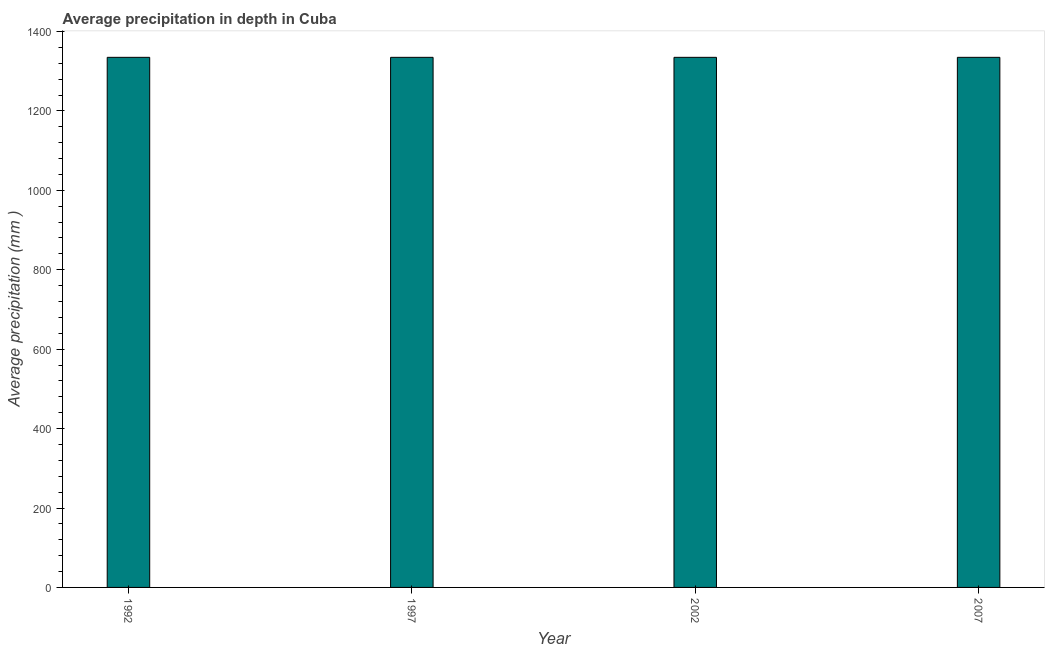What is the title of the graph?
Offer a very short reply. Average precipitation in depth in Cuba. What is the label or title of the X-axis?
Your response must be concise. Year. What is the label or title of the Y-axis?
Keep it short and to the point. Average precipitation (mm ). What is the average precipitation in depth in 2002?
Your answer should be compact. 1335. Across all years, what is the maximum average precipitation in depth?
Ensure brevity in your answer.  1335. Across all years, what is the minimum average precipitation in depth?
Make the answer very short. 1335. What is the sum of the average precipitation in depth?
Keep it short and to the point. 5340. What is the average average precipitation in depth per year?
Your answer should be very brief. 1335. What is the median average precipitation in depth?
Your answer should be very brief. 1335. What is the ratio of the average precipitation in depth in 1992 to that in 1997?
Offer a terse response. 1. Is the average precipitation in depth in 1992 less than that in 2002?
Give a very brief answer. No. What is the difference between the highest and the second highest average precipitation in depth?
Make the answer very short. 0. How many bars are there?
Your answer should be compact. 4. What is the difference between two consecutive major ticks on the Y-axis?
Provide a succinct answer. 200. Are the values on the major ticks of Y-axis written in scientific E-notation?
Your answer should be compact. No. What is the Average precipitation (mm ) in 1992?
Offer a terse response. 1335. What is the Average precipitation (mm ) in 1997?
Keep it short and to the point. 1335. What is the Average precipitation (mm ) in 2002?
Ensure brevity in your answer.  1335. What is the Average precipitation (mm ) of 2007?
Offer a terse response. 1335. What is the difference between the Average precipitation (mm ) in 1992 and 2002?
Keep it short and to the point. 0. What is the difference between the Average precipitation (mm ) in 1997 and 2007?
Offer a very short reply. 0. What is the ratio of the Average precipitation (mm ) in 1992 to that in 1997?
Make the answer very short. 1. What is the ratio of the Average precipitation (mm ) in 1992 to that in 2002?
Provide a succinct answer. 1. What is the ratio of the Average precipitation (mm ) in 1992 to that in 2007?
Provide a short and direct response. 1. What is the ratio of the Average precipitation (mm ) in 1997 to that in 2002?
Your answer should be very brief. 1. 